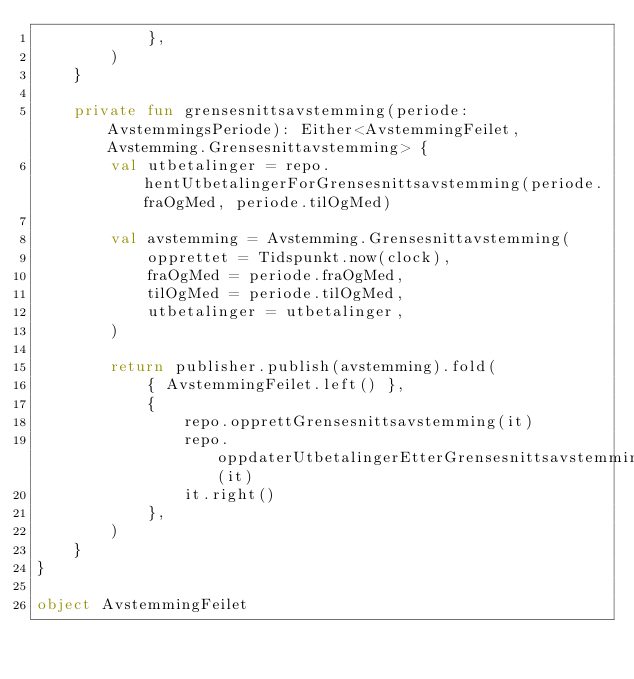<code> <loc_0><loc_0><loc_500><loc_500><_Kotlin_>            },
        )
    }

    private fun grensesnittsavstemming(periode: AvstemmingsPeriode): Either<AvstemmingFeilet, Avstemming.Grensesnittavstemming> {
        val utbetalinger = repo.hentUtbetalingerForGrensesnittsavstemming(periode.fraOgMed, periode.tilOgMed)

        val avstemming = Avstemming.Grensesnittavstemming(
            opprettet = Tidspunkt.now(clock),
            fraOgMed = periode.fraOgMed,
            tilOgMed = periode.tilOgMed,
            utbetalinger = utbetalinger,
        )

        return publisher.publish(avstemming).fold(
            { AvstemmingFeilet.left() },
            {
                repo.opprettGrensesnittsavstemming(it)
                repo.oppdaterUtbetalingerEtterGrensesnittsavstemming(it)
                it.right()
            },
        )
    }
}

object AvstemmingFeilet
</code> 